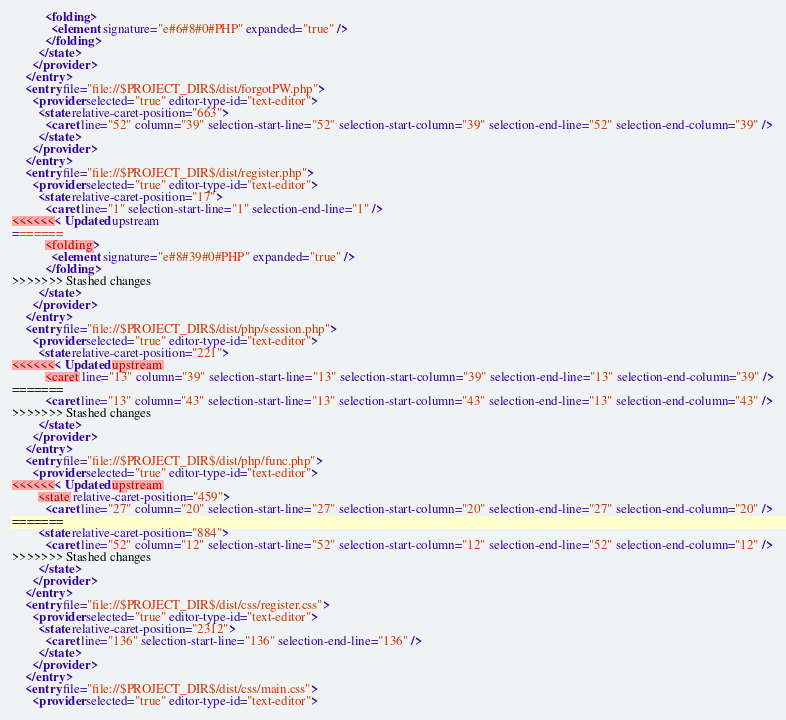Convert code to text. <code><loc_0><loc_0><loc_500><loc_500><_XML_>          <folding>
            <element signature="e#6#8#0#PHP" expanded="true" />
          </folding>
        </state>
      </provider>
    </entry>
    <entry file="file://$PROJECT_DIR$/dist/forgotPW.php">
      <provider selected="true" editor-type-id="text-editor">
        <state relative-caret-position="663">
          <caret line="52" column="39" selection-start-line="52" selection-start-column="39" selection-end-line="52" selection-end-column="39" />
        </state>
      </provider>
    </entry>
    <entry file="file://$PROJECT_DIR$/dist/register.php">
      <provider selected="true" editor-type-id="text-editor">
        <state relative-caret-position="17">
          <caret line="1" selection-start-line="1" selection-end-line="1" />
<<<<<<< Updated upstream
=======
          <folding>
            <element signature="e#8#39#0#PHP" expanded="true" />
          </folding>
>>>>>>> Stashed changes
        </state>
      </provider>
    </entry>
    <entry file="file://$PROJECT_DIR$/dist/php/session.php">
      <provider selected="true" editor-type-id="text-editor">
        <state relative-caret-position="221">
<<<<<<< Updated upstream
          <caret line="13" column="39" selection-start-line="13" selection-start-column="39" selection-end-line="13" selection-end-column="39" />
=======
          <caret line="13" column="43" selection-start-line="13" selection-start-column="43" selection-end-line="13" selection-end-column="43" />
>>>>>>> Stashed changes
        </state>
      </provider>
    </entry>
    <entry file="file://$PROJECT_DIR$/dist/php/func.php">
      <provider selected="true" editor-type-id="text-editor">
<<<<<<< Updated upstream
        <state relative-caret-position="459">
          <caret line="27" column="20" selection-start-line="27" selection-start-column="20" selection-end-line="27" selection-end-column="20" />
=======
        <state relative-caret-position="884">
          <caret line="52" column="12" selection-start-line="52" selection-start-column="12" selection-end-line="52" selection-end-column="12" />
>>>>>>> Stashed changes
        </state>
      </provider>
    </entry>
    <entry file="file://$PROJECT_DIR$/dist/css/register.css">
      <provider selected="true" editor-type-id="text-editor">
        <state relative-caret-position="2312">
          <caret line="136" selection-start-line="136" selection-end-line="136" />
        </state>
      </provider>
    </entry>
    <entry file="file://$PROJECT_DIR$/dist/css/main.css">
      <provider selected="true" editor-type-id="text-editor"></code> 